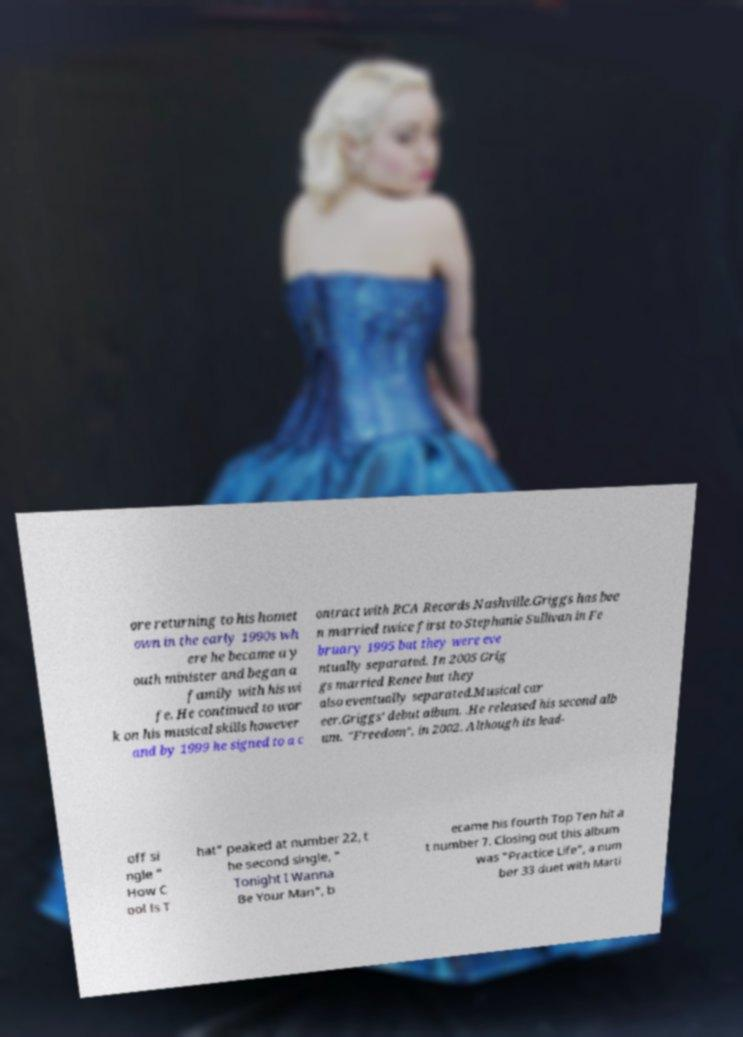Could you assist in decoding the text presented in this image and type it out clearly? ore returning to his homet own in the early 1990s wh ere he became a y outh minister and began a family with his wi fe. He continued to wor k on his musical skills however and by 1999 he signed to a c ontract with RCA Records Nashville.Griggs has bee n married twice first to Stephanie Sullivan in Fe bruary 1995 but they were eve ntually separated. In 2005 Grig gs married Renee but they also eventually separated.Musical car eer.Griggs' debut album, .He released his second alb um, "Freedom", in 2002. Although its lead- off si ngle " How C ool Is T hat" peaked at number 22, t he second single, " Tonight I Wanna Be Your Man", b ecame his fourth Top Ten hit a t number 7. Closing out this album was "Practice Life", a num ber 33 duet with Marti 